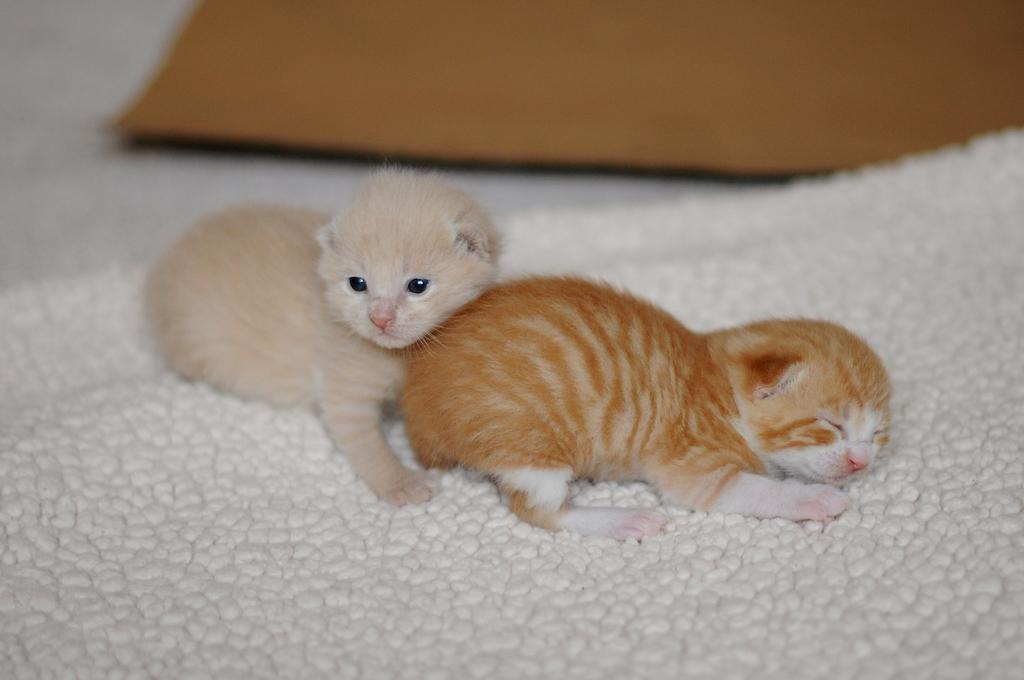How many cats are in the image? There are two cats in the image. What colors are the cats? The cats are in brown, cream, and white colors. Where are the cats located in the image? The cats are on a white surface. What can be seen in the background of the image? There is a brown color object in the background of the image. What type of organization do the cats belong to in the image? There is no indication in the image that the cats belong to any organization. 